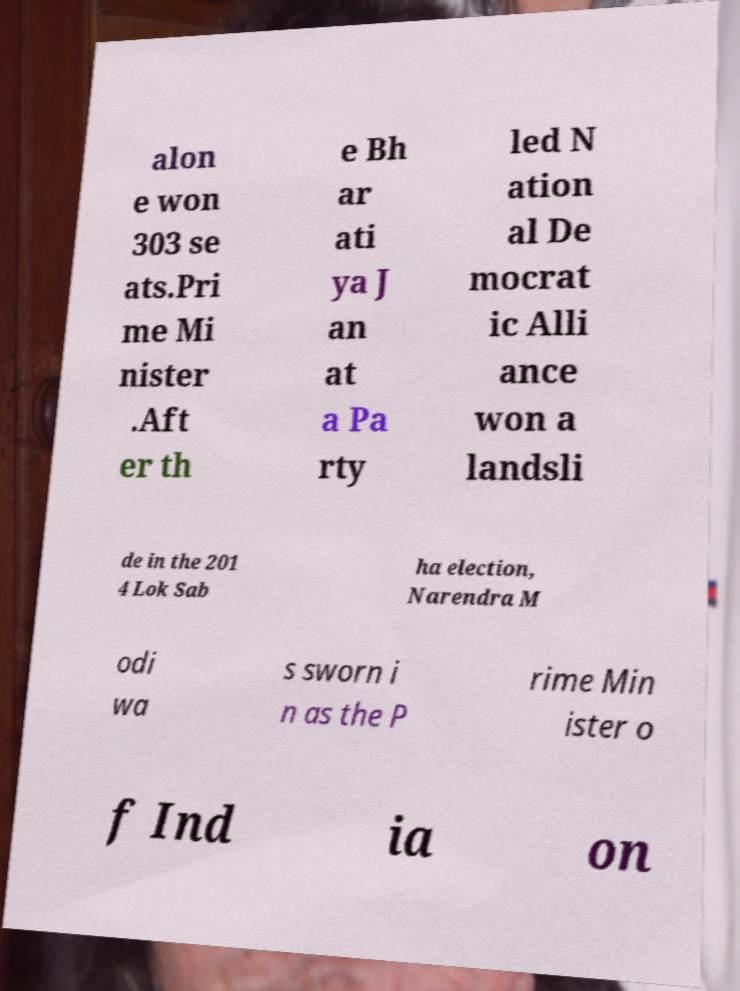There's text embedded in this image that I need extracted. Can you transcribe it verbatim? alon e won 303 se ats.Pri me Mi nister .Aft er th e Bh ar ati ya J an at a Pa rty led N ation al De mocrat ic Alli ance won a landsli de in the 201 4 Lok Sab ha election, Narendra M odi wa s sworn i n as the P rime Min ister o f Ind ia on 